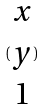Convert formula to latex. <formula><loc_0><loc_0><loc_500><loc_500>( \begin{matrix} x \\ y \\ 1 \end{matrix} )</formula> 